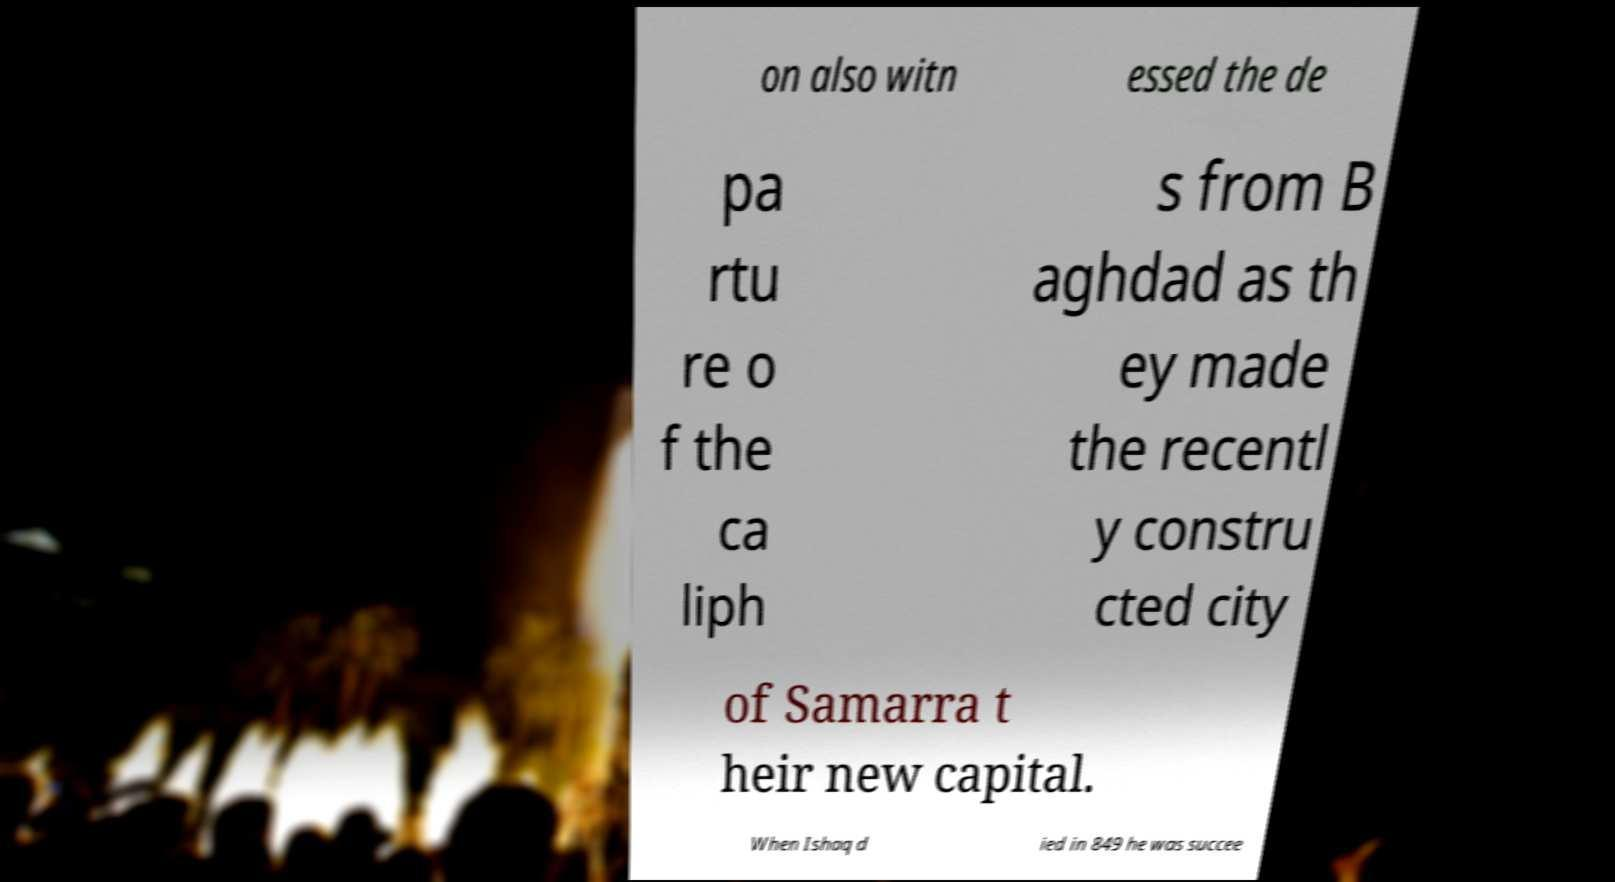Could you extract and type out the text from this image? on also witn essed the de pa rtu re o f the ca liph s from B aghdad as th ey made the recentl y constru cted city of Samarra t heir new capital. When Ishaq d ied in 849 he was succee 